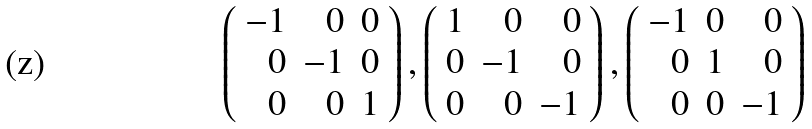<formula> <loc_0><loc_0><loc_500><loc_500>\left ( \begin{array} { r r r } - 1 & 0 & 0 \\ 0 & - 1 & 0 \\ 0 & 0 & 1 \end{array} \right ) , \left ( \begin{array} { r r r } 1 & 0 & 0 \\ 0 & - 1 & 0 \\ 0 & 0 & - 1 \end{array} \right ) , \left ( \begin{array} { r r r } - 1 & 0 & 0 \\ 0 & 1 & 0 \\ 0 & 0 & - 1 \end{array} \right )</formula> 